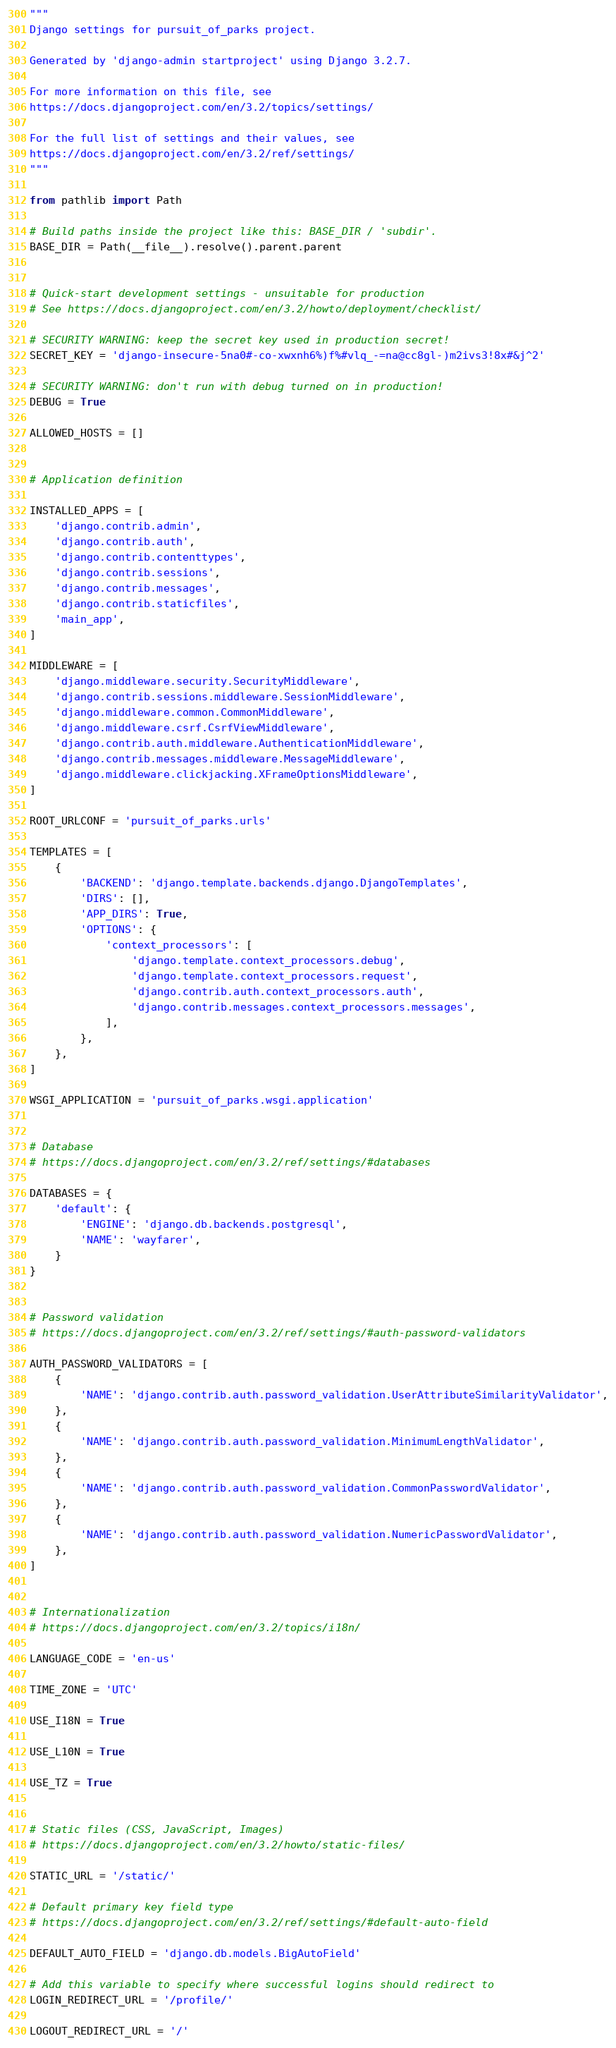Convert code to text. <code><loc_0><loc_0><loc_500><loc_500><_Python_>"""
Django settings for pursuit_of_parks project.

Generated by 'django-admin startproject' using Django 3.2.7.

For more information on this file, see
https://docs.djangoproject.com/en/3.2/topics/settings/

For the full list of settings and their values, see
https://docs.djangoproject.com/en/3.2/ref/settings/
"""

from pathlib import Path

# Build paths inside the project like this: BASE_DIR / 'subdir'.
BASE_DIR = Path(__file__).resolve().parent.parent


# Quick-start development settings - unsuitable for production
# See https://docs.djangoproject.com/en/3.2/howto/deployment/checklist/

# SECURITY WARNING: keep the secret key used in production secret!
SECRET_KEY = 'django-insecure-5na0#-co-xwxnh6%)f%#vlq_-=na@cc8gl-)m2ivs3!8x#&j^2'

# SECURITY WARNING: don't run with debug turned on in production!
DEBUG = True

ALLOWED_HOSTS = []


# Application definition

INSTALLED_APPS = [
    'django.contrib.admin',
    'django.contrib.auth',
    'django.contrib.contenttypes',
    'django.contrib.sessions',
    'django.contrib.messages',
    'django.contrib.staticfiles',
    'main_app',
]

MIDDLEWARE = [
    'django.middleware.security.SecurityMiddleware',
    'django.contrib.sessions.middleware.SessionMiddleware',
    'django.middleware.common.CommonMiddleware',
    'django.middleware.csrf.CsrfViewMiddleware',
    'django.contrib.auth.middleware.AuthenticationMiddleware',
    'django.contrib.messages.middleware.MessageMiddleware',
    'django.middleware.clickjacking.XFrameOptionsMiddleware',
]

ROOT_URLCONF = 'pursuit_of_parks.urls'

TEMPLATES = [
    {
        'BACKEND': 'django.template.backends.django.DjangoTemplates',
        'DIRS': [],
        'APP_DIRS': True,
        'OPTIONS': {
            'context_processors': [
                'django.template.context_processors.debug',
                'django.template.context_processors.request',
                'django.contrib.auth.context_processors.auth',
                'django.contrib.messages.context_processors.messages',
            ],
        },
    },
]

WSGI_APPLICATION = 'pursuit_of_parks.wsgi.application'


# Database
# https://docs.djangoproject.com/en/3.2/ref/settings/#databases

DATABASES = {
    'default': {
        'ENGINE': 'django.db.backends.postgresql',
        'NAME': 'wayfarer',
    }
}


# Password validation
# https://docs.djangoproject.com/en/3.2/ref/settings/#auth-password-validators

AUTH_PASSWORD_VALIDATORS = [
    {
        'NAME': 'django.contrib.auth.password_validation.UserAttributeSimilarityValidator',
    },
    {
        'NAME': 'django.contrib.auth.password_validation.MinimumLengthValidator',
    },
    {
        'NAME': 'django.contrib.auth.password_validation.CommonPasswordValidator',
    },
    {
        'NAME': 'django.contrib.auth.password_validation.NumericPasswordValidator',
    },
]


# Internationalization
# https://docs.djangoproject.com/en/3.2/topics/i18n/

LANGUAGE_CODE = 'en-us'

TIME_ZONE = 'UTC'

USE_I18N = True

USE_L10N = True

USE_TZ = True


# Static files (CSS, JavaScript, Images)
# https://docs.djangoproject.com/en/3.2/howto/static-files/

STATIC_URL = '/static/'

# Default primary key field type
# https://docs.djangoproject.com/en/3.2/ref/settings/#default-auto-field

DEFAULT_AUTO_FIELD = 'django.db.models.BigAutoField'

# Add this variable to specify where successful logins should redirect to
LOGIN_REDIRECT_URL = '/profile/'

LOGOUT_REDIRECT_URL = '/'</code> 